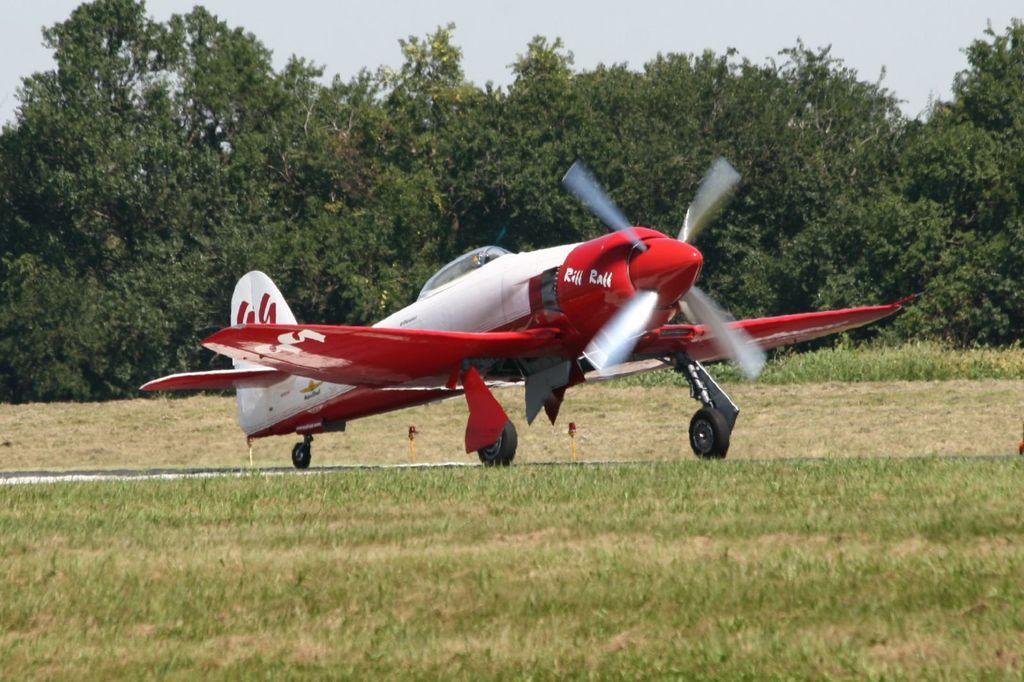How would you summarize this image in a sentence or two? In the center of the image we can see a helicopter. At the bottom there is grass. In the background there are trees and sky. 